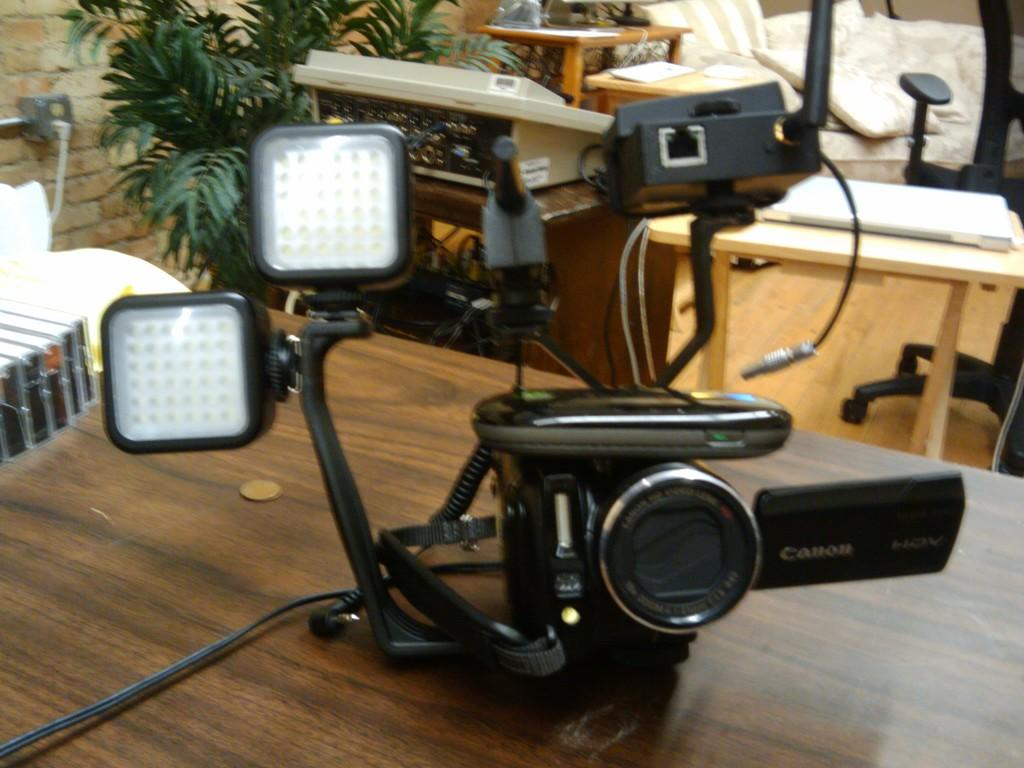What object is on the table in the image? There is a camera on the table in the image. What brand is the camera? The camera has the name "Canon" written on it. What can be seen in the background of the image? There is a chair, a table, plants, and a wall in the background. What type of thrill can be experienced by the camera in the image? The camera in the image is not experiencing any thrill, as it is an inanimate object. What is the end result of the camera in the image? The camera in the image is not producing any end result, as it is not being used to take a photograph. 